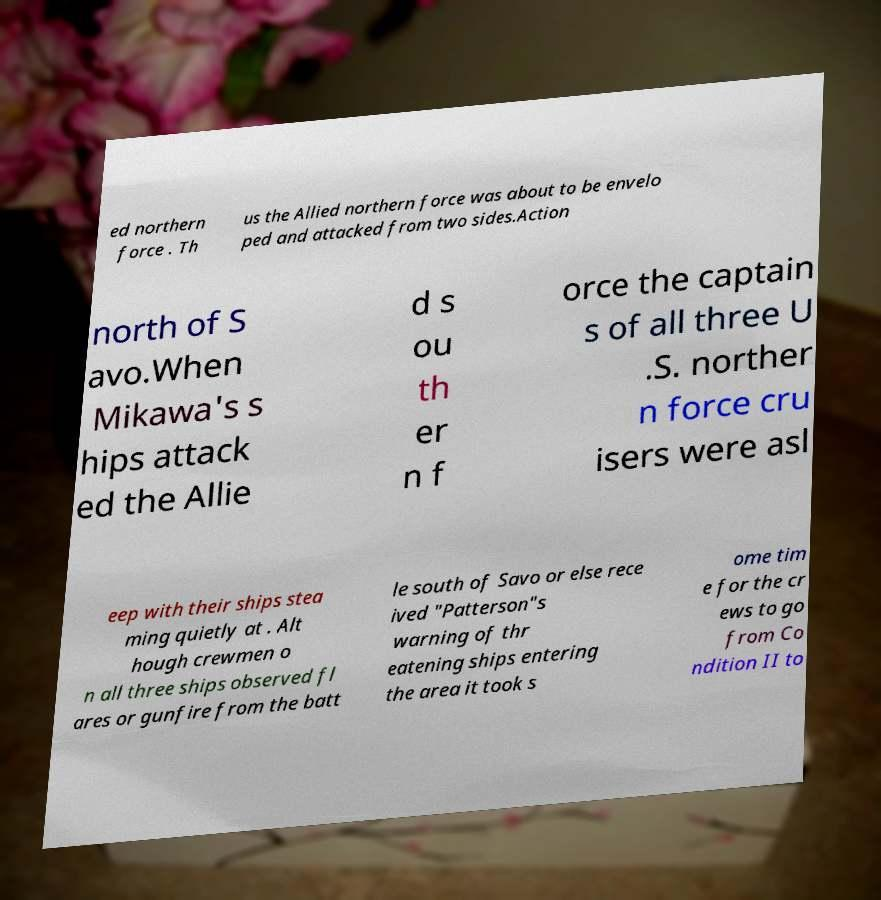Could you extract and type out the text from this image? ed northern force . Th us the Allied northern force was about to be envelo ped and attacked from two sides.Action north of S avo.When Mikawa's s hips attack ed the Allie d s ou th er n f orce the captain s of all three U .S. norther n force cru isers were asl eep with their ships stea ming quietly at . Alt hough crewmen o n all three ships observed fl ares or gunfire from the batt le south of Savo or else rece ived "Patterson"s warning of thr eatening ships entering the area it took s ome tim e for the cr ews to go from Co ndition II to 